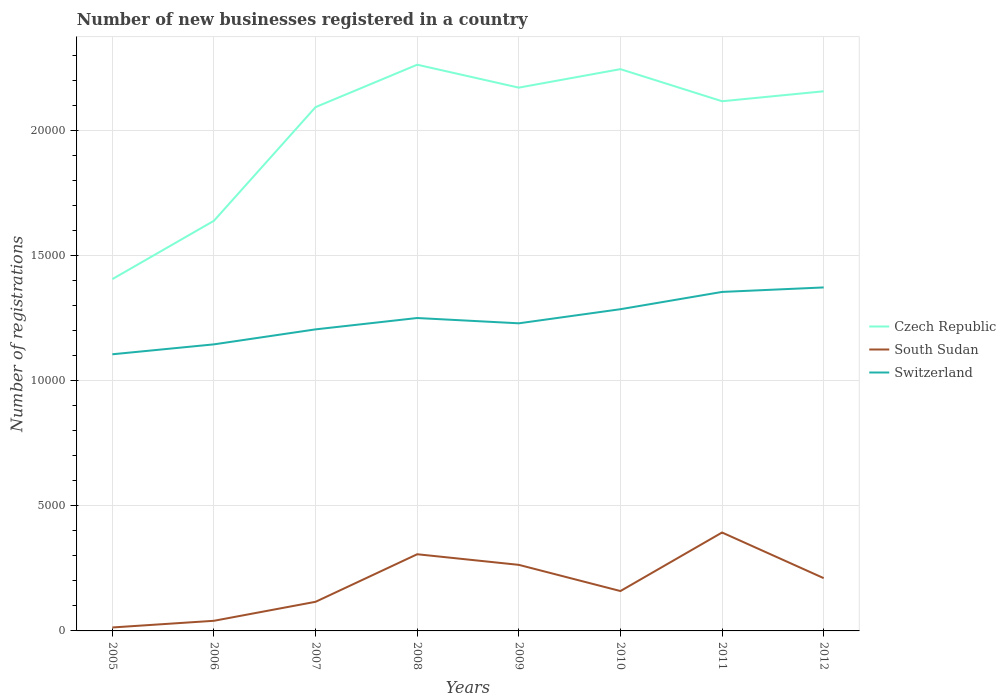Is the number of lines equal to the number of legend labels?
Keep it short and to the point. Yes. Across all years, what is the maximum number of new businesses registered in South Sudan?
Your answer should be very brief. 138. In which year was the number of new businesses registered in Czech Republic maximum?
Ensure brevity in your answer.  2005. What is the total number of new businesses registered in South Sudan in the graph?
Offer a terse response. -430. What is the difference between the highest and the second highest number of new businesses registered in Switzerland?
Make the answer very short. 2672. Is the number of new businesses registered in South Sudan strictly greater than the number of new businesses registered in Czech Republic over the years?
Your answer should be very brief. Yes. How many years are there in the graph?
Make the answer very short. 8. Does the graph contain any zero values?
Offer a terse response. No. Does the graph contain grids?
Your answer should be very brief. Yes. Where does the legend appear in the graph?
Your answer should be very brief. Center right. How many legend labels are there?
Make the answer very short. 3. What is the title of the graph?
Make the answer very short. Number of new businesses registered in a country. Does "Ecuador" appear as one of the legend labels in the graph?
Make the answer very short. No. What is the label or title of the Y-axis?
Your answer should be very brief. Number of registrations. What is the Number of registrations in Czech Republic in 2005?
Your answer should be compact. 1.41e+04. What is the Number of registrations of South Sudan in 2005?
Give a very brief answer. 138. What is the Number of registrations of Switzerland in 2005?
Keep it short and to the point. 1.11e+04. What is the Number of registrations of Czech Republic in 2006?
Ensure brevity in your answer.  1.64e+04. What is the Number of registrations of South Sudan in 2006?
Ensure brevity in your answer.  405. What is the Number of registrations in Switzerland in 2006?
Offer a very short reply. 1.15e+04. What is the Number of registrations in Czech Republic in 2007?
Your answer should be very brief. 2.09e+04. What is the Number of registrations of South Sudan in 2007?
Your answer should be compact. 1164. What is the Number of registrations of Switzerland in 2007?
Ensure brevity in your answer.  1.21e+04. What is the Number of registrations of Czech Republic in 2008?
Provide a short and direct response. 2.26e+04. What is the Number of registrations in South Sudan in 2008?
Make the answer very short. 3065. What is the Number of registrations in Switzerland in 2008?
Provide a succinct answer. 1.25e+04. What is the Number of registrations in Czech Republic in 2009?
Keep it short and to the point. 2.17e+04. What is the Number of registrations in South Sudan in 2009?
Make the answer very short. 2641. What is the Number of registrations of Switzerland in 2009?
Make the answer very short. 1.23e+04. What is the Number of registrations in Czech Republic in 2010?
Your response must be concise. 2.25e+04. What is the Number of registrations of South Sudan in 2010?
Provide a short and direct response. 1594. What is the Number of registrations of Switzerland in 2010?
Provide a succinct answer. 1.29e+04. What is the Number of registrations of Czech Republic in 2011?
Offer a terse response. 2.12e+04. What is the Number of registrations of South Sudan in 2011?
Your answer should be compact. 3934. What is the Number of registrations in Switzerland in 2011?
Keep it short and to the point. 1.36e+04. What is the Number of registrations of Czech Republic in 2012?
Ensure brevity in your answer.  2.16e+04. What is the Number of registrations in South Sudan in 2012?
Your response must be concise. 2110. What is the Number of registrations of Switzerland in 2012?
Offer a very short reply. 1.37e+04. Across all years, what is the maximum Number of registrations in Czech Republic?
Keep it short and to the point. 2.26e+04. Across all years, what is the maximum Number of registrations of South Sudan?
Provide a short and direct response. 3934. Across all years, what is the maximum Number of registrations in Switzerland?
Make the answer very short. 1.37e+04. Across all years, what is the minimum Number of registrations in Czech Republic?
Your answer should be compact. 1.41e+04. Across all years, what is the minimum Number of registrations in South Sudan?
Offer a very short reply. 138. Across all years, what is the minimum Number of registrations of Switzerland?
Your answer should be compact. 1.11e+04. What is the total Number of registrations in Czech Republic in the graph?
Provide a short and direct response. 1.61e+05. What is the total Number of registrations of South Sudan in the graph?
Provide a succinct answer. 1.51e+04. What is the total Number of registrations of Switzerland in the graph?
Your answer should be compact. 9.95e+04. What is the difference between the Number of registrations of Czech Republic in 2005 and that in 2006?
Your answer should be compact. -2333. What is the difference between the Number of registrations of South Sudan in 2005 and that in 2006?
Keep it short and to the point. -267. What is the difference between the Number of registrations of Switzerland in 2005 and that in 2006?
Provide a succinct answer. -397. What is the difference between the Number of registrations in Czech Republic in 2005 and that in 2007?
Ensure brevity in your answer.  -6876. What is the difference between the Number of registrations of South Sudan in 2005 and that in 2007?
Make the answer very short. -1026. What is the difference between the Number of registrations of Switzerland in 2005 and that in 2007?
Offer a very short reply. -996. What is the difference between the Number of registrations in Czech Republic in 2005 and that in 2008?
Provide a short and direct response. -8571. What is the difference between the Number of registrations of South Sudan in 2005 and that in 2008?
Provide a short and direct response. -2927. What is the difference between the Number of registrations of Switzerland in 2005 and that in 2008?
Keep it short and to the point. -1450. What is the difference between the Number of registrations of Czech Republic in 2005 and that in 2009?
Offer a very short reply. -7655. What is the difference between the Number of registrations in South Sudan in 2005 and that in 2009?
Keep it short and to the point. -2503. What is the difference between the Number of registrations of Switzerland in 2005 and that in 2009?
Provide a succinct answer. -1238. What is the difference between the Number of registrations of Czech Republic in 2005 and that in 2010?
Ensure brevity in your answer.  -8394. What is the difference between the Number of registrations in South Sudan in 2005 and that in 2010?
Give a very brief answer. -1456. What is the difference between the Number of registrations of Switzerland in 2005 and that in 2010?
Offer a terse response. -1802. What is the difference between the Number of registrations in Czech Republic in 2005 and that in 2011?
Provide a succinct answer. -7111. What is the difference between the Number of registrations in South Sudan in 2005 and that in 2011?
Provide a succinct answer. -3796. What is the difference between the Number of registrations of Switzerland in 2005 and that in 2011?
Make the answer very short. -2493. What is the difference between the Number of registrations in Czech Republic in 2005 and that in 2012?
Offer a terse response. -7509. What is the difference between the Number of registrations in South Sudan in 2005 and that in 2012?
Make the answer very short. -1972. What is the difference between the Number of registrations of Switzerland in 2005 and that in 2012?
Your response must be concise. -2672. What is the difference between the Number of registrations in Czech Republic in 2006 and that in 2007?
Your response must be concise. -4543. What is the difference between the Number of registrations of South Sudan in 2006 and that in 2007?
Make the answer very short. -759. What is the difference between the Number of registrations in Switzerland in 2006 and that in 2007?
Offer a very short reply. -599. What is the difference between the Number of registrations of Czech Republic in 2006 and that in 2008?
Make the answer very short. -6238. What is the difference between the Number of registrations in South Sudan in 2006 and that in 2008?
Make the answer very short. -2660. What is the difference between the Number of registrations of Switzerland in 2006 and that in 2008?
Provide a succinct answer. -1053. What is the difference between the Number of registrations of Czech Republic in 2006 and that in 2009?
Provide a succinct answer. -5322. What is the difference between the Number of registrations of South Sudan in 2006 and that in 2009?
Your response must be concise. -2236. What is the difference between the Number of registrations of Switzerland in 2006 and that in 2009?
Your answer should be compact. -841. What is the difference between the Number of registrations of Czech Republic in 2006 and that in 2010?
Ensure brevity in your answer.  -6061. What is the difference between the Number of registrations of South Sudan in 2006 and that in 2010?
Provide a succinct answer. -1189. What is the difference between the Number of registrations of Switzerland in 2006 and that in 2010?
Ensure brevity in your answer.  -1405. What is the difference between the Number of registrations in Czech Republic in 2006 and that in 2011?
Provide a succinct answer. -4778. What is the difference between the Number of registrations in South Sudan in 2006 and that in 2011?
Offer a very short reply. -3529. What is the difference between the Number of registrations of Switzerland in 2006 and that in 2011?
Keep it short and to the point. -2096. What is the difference between the Number of registrations of Czech Republic in 2006 and that in 2012?
Ensure brevity in your answer.  -5176. What is the difference between the Number of registrations of South Sudan in 2006 and that in 2012?
Your response must be concise. -1705. What is the difference between the Number of registrations of Switzerland in 2006 and that in 2012?
Provide a short and direct response. -2275. What is the difference between the Number of registrations in Czech Republic in 2007 and that in 2008?
Offer a very short reply. -1695. What is the difference between the Number of registrations of South Sudan in 2007 and that in 2008?
Your response must be concise. -1901. What is the difference between the Number of registrations of Switzerland in 2007 and that in 2008?
Offer a very short reply. -454. What is the difference between the Number of registrations of Czech Republic in 2007 and that in 2009?
Provide a short and direct response. -779. What is the difference between the Number of registrations of South Sudan in 2007 and that in 2009?
Your response must be concise. -1477. What is the difference between the Number of registrations of Switzerland in 2007 and that in 2009?
Give a very brief answer. -242. What is the difference between the Number of registrations of Czech Republic in 2007 and that in 2010?
Provide a succinct answer. -1518. What is the difference between the Number of registrations of South Sudan in 2007 and that in 2010?
Provide a short and direct response. -430. What is the difference between the Number of registrations in Switzerland in 2007 and that in 2010?
Offer a terse response. -806. What is the difference between the Number of registrations in Czech Republic in 2007 and that in 2011?
Make the answer very short. -235. What is the difference between the Number of registrations in South Sudan in 2007 and that in 2011?
Keep it short and to the point. -2770. What is the difference between the Number of registrations in Switzerland in 2007 and that in 2011?
Your response must be concise. -1497. What is the difference between the Number of registrations of Czech Republic in 2007 and that in 2012?
Offer a terse response. -633. What is the difference between the Number of registrations of South Sudan in 2007 and that in 2012?
Your answer should be very brief. -946. What is the difference between the Number of registrations in Switzerland in 2007 and that in 2012?
Ensure brevity in your answer.  -1676. What is the difference between the Number of registrations in Czech Republic in 2008 and that in 2009?
Provide a short and direct response. 916. What is the difference between the Number of registrations in South Sudan in 2008 and that in 2009?
Keep it short and to the point. 424. What is the difference between the Number of registrations in Switzerland in 2008 and that in 2009?
Offer a very short reply. 212. What is the difference between the Number of registrations in Czech Republic in 2008 and that in 2010?
Give a very brief answer. 177. What is the difference between the Number of registrations in South Sudan in 2008 and that in 2010?
Make the answer very short. 1471. What is the difference between the Number of registrations of Switzerland in 2008 and that in 2010?
Your answer should be very brief. -352. What is the difference between the Number of registrations of Czech Republic in 2008 and that in 2011?
Ensure brevity in your answer.  1460. What is the difference between the Number of registrations of South Sudan in 2008 and that in 2011?
Your answer should be compact. -869. What is the difference between the Number of registrations in Switzerland in 2008 and that in 2011?
Provide a short and direct response. -1043. What is the difference between the Number of registrations in Czech Republic in 2008 and that in 2012?
Provide a succinct answer. 1062. What is the difference between the Number of registrations in South Sudan in 2008 and that in 2012?
Offer a very short reply. 955. What is the difference between the Number of registrations in Switzerland in 2008 and that in 2012?
Offer a terse response. -1222. What is the difference between the Number of registrations in Czech Republic in 2009 and that in 2010?
Provide a succinct answer. -739. What is the difference between the Number of registrations in South Sudan in 2009 and that in 2010?
Your answer should be compact. 1047. What is the difference between the Number of registrations in Switzerland in 2009 and that in 2010?
Offer a terse response. -564. What is the difference between the Number of registrations in Czech Republic in 2009 and that in 2011?
Ensure brevity in your answer.  544. What is the difference between the Number of registrations in South Sudan in 2009 and that in 2011?
Keep it short and to the point. -1293. What is the difference between the Number of registrations in Switzerland in 2009 and that in 2011?
Make the answer very short. -1255. What is the difference between the Number of registrations of Czech Republic in 2009 and that in 2012?
Keep it short and to the point. 146. What is the difference between the Number of registrations in South Sudan in 2009 and that in 2012?
Ensure brevity in your answer.  531. What is the difference between the Number of registrations in Switzerland in 2009 and that in 2012?
Provide a short and direct response. -1434. What is the difference between the Number of registrations in Czech Republic in 2010 and that in 2011?
Your response must be concise. 1283. What is the difference between the Number of registrations in South Sudan in 2010 and that in 2011?
Ensure brevity in your answer.  -2340. What is the difference between the Number of registrations of Switzerland in 2010 and that in 2011?
Keep it short and to the point. -691. What is the difference between the Number of registrations in Czech Republic in 2010 and that in 2012?
Your answer should be very brief. 885. What is the difference between the Number of registrations of South Sudan in 2010 and that in 2012?
Give a very brief answer. -516. What is the difference between the Number of registrations in Switzerland in 2010 and that in 2012?
Your response must be concise. -870. What is the difference between the Number of registrations of Czech Republic in 2011 and that in 2012?
Your response must be concise. -398. What is the difference between the Number of registrations of South Sudan in 2011 and that in 2012?
Ensure brevity in your answer.  1824. What is the difference between the Number of registrations of Switzerland in 2011 and that in 2012?
Your answer should be compact. -179. What is the difference between the Number of registrations in Czech Republic in 2005 and the Number of registrations in South Sudan in 2006?
Provide a succinct answer. 1.37e+04. What is the difference between the Number of registrations of Czech Republic in 2005 and the Number of registrations of Switzerland in 2006?
Ensure brevity in your answer.  2607. What is the difference between the Number of registrations of South Sudan in 2005 and the Number of registrations of Switzerland in 2006?
Offer a terse response. -1.13e+04. What is the difference between the Number of registrations of Czech Republic in 2005 and the Number of registrations of South Sudan in 2007?
Your answer should be very brief. 1.29e+04. What is the difference between the Number of registrations in Czech Republic in 2005 and the Number of registrations in Switzerland in 2007?
Your answer should be very brief. 2008. What is the difference between the Number of registrations of South Sudan in 2005 and the Number of registrations of Switzerland in 2007?
Your response must be concise. -1.19e+04. What is the difference between the Number of registrations in Czech Republic in 2005 and the Number of registrations in South Sudan in 2008?
Keep it short and to the point. 1.10e+04. What is the difference between the Number of registrations in Czech Republic in 2005 and the Number of registrations in Switzerland in 2008?
Your answer should be very brief. 1554. What is the difference between the Number of registrations in South Sudan in 2005 and the Number of registrations in Switzerland in 2008?
Provide a short and direct response. -1.24e+04. What is the difference between the Number of registrations in Czech Republic in 2005 and the Number of registrations in South Sudan in 2009?
Make the answer very short. 1.14e+04. What is the difference between the Number of registrations of Czech Republic in 2005 and the Number of registrations of Switzerland in 2009?
Provide a succinct answer. 1766. What is the difference between the Number of registrations in South Sudan in 2005 and the Number of registrations in Switzerland in 2009?
Your response must be concise. -1.22e+04. What is the difference between the Number of registrations of Czech Republic in 2005 and the Number of registrations of South Sudan in 2010?
Make the answer very short. 1.25e+04. What is the difference between the Number of registrations in Czech Republic in 2005 and the Number of registrations in Switzerland in 2010?
Keep it short and to the point. 1202. What is the difference between the Number of registrations in South Sudan in 2005 and the Number of registrations in Switzerland in 2010?
Your response must be concise. -1.27e+04. What is the difference between the Number of registrations of Czech Republic in 2005 and the Number of registrations of South Sudan in 2011?
Your response must be concise. 1.01e+04. What is the difference between the Number of registrations of Czech Republic in 2005 and the Number of registrations of Switzerland in 2011?
Keep it short and to the point. 511. What is the difference between the Number of registrations in South Sudan in 2005 and the Number of registrations in Switzerland in 2011?
Your response must be concise. -1.34e+04. What is the difference between the Number of registrations of Czech Republic in 2005 and the Number of registrations of South Sudan in 2012?
Give a very brief answer. 1.20e+04. What is the difference between the Number of registrations of Czech Republic in 2005 and the Number of registrations of Switzerland in 2012?
Offer a very short reply. 332. What is the difference between the Number of registrations in South Sudan in 2005 and the Number of registrations in Switzerland in 2012?
Make the answer very short. -1.36e+04. What is the difference between the Number of registrations of Czech Republic in 2006 and the Number of registrations of South Sudan in 2007?
Keep it short and to the point. 1.52e+04. What is the difference between the Number of registrations of Czech Republic in 2006 and the Number of registrations of Switzerland in 2007?
Your answer should be compact. 4341. What is the difference between the Number of registrations in South Sudan in 2006 and the Number of registrations in Switzerland in 2007?
Provide a succinct answer. -1.16e+04. What is the difference between the Number of registrations of Czech Republic in 2006 and the Number of registrations of South Sudan in 2008?
Give a very brief answer. 1.33e+04. What is the difference between the Number of registrations of Czech Republic in 2006 and the Number of registrations of Switzerland in 2008?
Offer a terse response. 3887. What is the difference between the Number of registrations of South Sudan in 2006 and the Number of registrations of Switzerland in 2008?
Your response must be concise. -1.21e+04. What is the difference between the Number of registrations of Czech Republic in 2006 and the Number of registrations of South Sudan in 2009?
Make the answer very short. 1.38e+04. What is the difference between the Number of registrations in Czech Republic in 2006 and the Number of registrations in Switzerland in 2009?
Make the answer very short. 4099. What is the difference between the Number of registrations of South Sudan in 2006 and the Number of registrations of Switzerland in 2009?
Ensure brevity in your answer.  -1.19e+04. What is the difference between the Number of registrations of Czech Republic in 2006 and the Number of registrations of South Sudan in 2010?
Ensure brevity in your answer.  1.48e+04. What is the difference between the Number of registrations in Czech Republic in 2006 and the Number of registrations in Switzerland in 2010?
Provide a short and direct response. 3535. What is the difference between the Number of registrations in South Sudan in 2006 and the Number of registrations in Switzerland in 2010?
Give a very brief answer. -1.25e+04. What is the difference between the Number of registrations in Czech Republic in 2006 and the Number of registrations in South Sudan in 2011?
Make the answer very short. 1.25e+04. What is the difference between the Number of registrations in Czech Republic in 2006 and the Number of registrations in Switzerland in 2011?
Ensure brevity in your answer.  2844. What is the difference between the Number of registrations of South Sudan in 2006 and the Number of registrations of Switzerland in 2011?
Offer a terse response. -1.31e+04. What is the difference between the Number of registrations of Czech Republic in 2006 and the Number of registrations of South Sudan in 2012?
Make the answer very short. 1.43e+04. What is the difference between the Number of registrations of Czech Republic in 2006 and the Number of registrations of Switzerland in 2012?
Your answer should be compact. 2665. What is the difference between the Number of registrations of South Sudan in 2006 and the Number of registrations of Switzerland in 2012?
Make the answer very short. -1.33e+04. What is the difference between the Number of registrations of Czech Republic in 2007 and the Number of registrations of South Sudan in 2008?
Your answer should be very brief. 1.79e+04. What is the difference between the Number of registrations in Czech Republic in 2007 and the Number of registrations in Switzerland in 2008?
Your answer should be compact. 8430. What is the difference between the Number of registrations in South Sudan in 2007 and the Number of registrations in Switzerland in 2008?
Give a very brief answer. -1.13e+04. What is the difference between the Number of registrations of Czech Republic in 2007 and the Number of registrations of South Sudan in 2009?
Ensure brevity in your answer.  1.83e+04. What is the difference between the Number of registrations in Czech Republic in 2007 and the Number of registrations in Switzerland in 2009?
Your answer should be compact. 8642. What is the difference between the Number of registrations of South Sudan in 2007 and the Number of registrations of Switzerland in 2009?
Ensure brevity in your answer.  -1.11e+04. What is the difference between the Number of registrations in Czech Republic in 2007 and the Number of registrations in South Sudan in 2010?
Ensure brevity in your answer.  1.93e+04. What is the difference between the Number of registrations of Czech Republic in 2007 and the Number of registrations of Switzerland in 2010?
Keep it short and to the point. 8078. What is the difference between the Number of registrations in South Sudan in 2007 and the Number of registrations in Switzerland in 2010?
Provide a short and direct response. -1.17e+04. What is the difference between the Number of registrations in Czech Republic in 2007 and the Number of registrations in South Sudan in 2011?
Your response must be concise. 1.70e+04. What is the difference between the Number of registrations in Czech Republic in 2007 and the Number of registrations in Switzerland in 2011?
Give a very brief answer. 7387. What is the difference between the Number of registrations of South Sudan in 2007 and the Number of registrations of Switzerland in 2011?
Give a very brief answer. -1.24e+04. What is the difference between the Number of registrations of Czech Republic in 2007 and the Number of registrations of South Sudan in 2012?
Keep it short and to the point. 1.88e+04. What is the difference between the Number of registrations of Czech Republic in 2007 and the Number of registrations of Switzerland in 2012?
Offer a very short reply. 7208. What is the difference between the Number of registrations in South Sudan in 2007 and the Number of registrations in Switzerland in 2012?
Your response must be concise. -1.26e+04. What is the difference between the Number of registrations in Czech Republic in 2008 and the Number of registrations in South Sudan in 2009?
Offer a terse response. 2.00e+04. What is the difference between the Number of registrations of Czech Republic in 2008 and the Number of registrations of Switzerland in 2009?
Provide a succinct answer. 1.03e+04. What is the difference between the Number of registrations in South Sudan in 2008 and the Number of registrations in Switzerland in 2009?
Provide a short and direct response. -9231. What is the difference between the Number of registrations in Czech Republic in 2008 and the Number of registrations in South Sudan in 2010?
Make the answer very short. 2.10e+04. What is the difference between the Number of registrations in Czech Republic in 2008 and the Number of registrations in Switzerland in 2010?
Make the answer very short. 9773. What is the difference between the Number of registrations in South Sudan in 2008 and the Number of registrations in Switzerland in 2010?
Your response must be concise. -9795. What is the difference between the Number of registrations in Czech Republic in 2008 and the Number of registrations in South Sudan in 2011?
Offer a terse response. 1.87e+04. What is the difference between the Number of registrations of Czech Republic in 2008 and the Number of registrations of Switzerland in 2011?
Your answer should be compact. 9082. What is the difference between the Number of registrations of South Sudan in 2008 and the Number of registrations of Switzerland in 2011?
Provide a short and direct response. -1.05e+04. What is the difference between the Number of registrations of Czech Republic in 2008 and the Number of registrations of South Sudan in 2012?
Make the answer very short. 2.05e+04. What is the difference between the Number of registrations of Czech Republic in 2008 and the Number of registrations of Switzerland in 2012?
Make the answer very short. 8903. What is the difference between the Number of registrations in South Sudan in 2008 and the Number of registrations in Switzerland in 2012?
Offer a terse response. -1.07e+04. What is the difference between the Number of registrations of Czech Republic in 2009 and the Number of registrations of South Sudan in 2010?
Provide a short and direct response. 2.01e+04. What is the difference between the Number of registrations in Czech Republic in 2009 and the Number of registrations in Switzerland in 2010?
Your response must be concise. 8857. What is the difference between the Number of registrations of South Sudan in 2009 and the Number of registrations of Switzerland in 2010?
Your answer should be compact. -1.02e+04. What is the difference between the Number of registrations in Czech Republic in 2009 and the Number of registrations in South Sudan in 2011?
Provide a succinct answer. 1.78e+04. What is the difference between the Number of registrations of Czech Republic in 2009 and the Number of registrations of Switzerland in 2011?
Ensure brevity in your answer.  8166. What is the difference between the Number of registrations in South Sudan in 2009 and the Number of registrations in Switzerland in 2011?
Your response must be concise. -1.09e+04. What is the difference between the Number of registrations of Czech Republic in 2009 and the Number of registrations of South Sudan in 2012?
Your answer should be compact. 1.96e+04. What is the difference between the Number of registrations in Czech Republic in 2009 and the Number of registrations in Switzerland in 2012?
Offer a very short reply. 7987. What is the difference between the Number of registrations in South Sudan in 2009 and the Number of registrations in Switzerland in 2012?
Provide a succinct answer. -1.11e+04. What is the difference between the Number of registrations of Czech Republic in 2010 and the Number of registrations of South Sudan in 2011?
Give a very brief answer. 1.85e+04. What is the difference between the Number of registrations in Czech Republic in 2010 and the Number of registrations in Switzerland in 2011?
Make the answer very short. 8905. What is the difference between the Number of registrations of South Sudan in 2010 and the Number of registrations of Switzerland in 2011?
Your answer should be compact. -1.20e+04. What is the difference between the Number of registrations in Czech Republic in 2010 and the Number of registrations in South Sudan in 2012?
Provide a short and direct response. 2.03e+04. What is the difference between the Number of registrations in Czech Republic in 2010 and the Number of registrations in Switzerland in 2012?
Ensure brevity in your answer.  8726. What is the difference between the Number of registrations of South Sudan in 2010 and the Number of registrations of Switzerland in 2012?
Ensure brevity in your answer.  -1.21e+04. What is the difference between the Number of registrations of Czech Republic in 2011 and the Number of registrations of South Sudan in 2012?
Keep it short and to the point. 1.91e+04. What is the difference between the Number of registrations of Czech Republic in 2011 and the Number of registrations of Switzerland in 2012?
Ensure brevity in your answer.  7443. What is the difference between the Number of registrations in South Sudan in 2011 and the Number of registrations in Switzerland in 2012?
Make the answer very short. -9796. What is the average Number of registrations of Czech Republic per year?
Provide a succinct answer. 2.01e+04. What is the average Number of registrations of South Sudan per year?
Your answer should be compact. 1881.38. What is the average Number of registrations in Switzerland per year?
Your response must be concise. 1.24e+04. In the year 2005, what is the difference between the Number of registrations of Czech Republic and Number of registrations of South Sudan?
Provide a succinct answer. 1.39e+04. In the year 2005, what is the difference between the Number of registrations of Czech Republic and Number of registrations of Switzerland?
Make the answer very short. 3004. In the year 2005, what is the difference between the Number of registrations in South Sudan and Number of registrations in Switzerland?
Make the answer very short. -1.09e+04. In the year 2006, what is the difference between the Number of registrations of Czech Republic and Number of registrations of South Sudan?
Your response must be concise. 1.60e+04. In the year 2006, what is the difference between the Number of registrations in Czech Republic and Number of registrations in Switzerland?
Your response must be concise. 4940. In the year 2006, what is the difference between the Number of registrations in South Sudan and Number of registrations in Switzerland?
Give a very brief answer. -1.10e+04. In the year 2007, what is the difference between the Number of registrations in Czech Republic and Number of registrations in South Sudan?
Your response must be concise. 1.98e+04. In the year 2007, what is the difference between the Number of registrations of Czech Republic and Number of registrations of Switzerland?
Provide a succinct answer. 8884. In the year 2007, what is the difference between the Number of registrations in South Sudan and Number of registrations in Switzerland?
Provide a short and direct response. -1.09e+04. In the year 2008, what is the difference between the Number of registrations of Czech Republic and Number of registrations of South Sudan?
Ensure brevity in your answer.  1.96e+04. In the year 2008, what is the difference between the Number of registrations in Czech Republic and Number of registrations in Switzerland?
Give a very brief answer. 1.01e+04. In the year 2008, what is the difference between the Number of registrations of South Sudan and Number of registrations of Switzerland?
Make the answer very short. -9443. In the year 2009, what is the difference between the Number of registrations in Czech Republic and Number of registrations in South Sudan?
Make the answer very short. 1.91e+04. In the year 2009, what is the difference between the Number of registrations of Czech Republic and Number of registrations of Switzerland?
Your answer should be very brief. 9421. In the year 2009, what is the difference between the Number of registrations of South Sudan and Number of registrations of Switzerland?
Offer a very short reply. -9655. In the year 2010, what is the difference between the Number of registrations of Czech Republic and Number of registrations of South Sudan?
Offer a terse response. 2.09e+04. In the year 2010, what is the difference between the Number of registrations in Czech Republic and Number of registrations in Switzerland?
Your answer should be compact. 9596. In the year 2010, what is the difference between the Number of registrations in South Sudan and Number of registrations in Switzerland?
Offer a terse response. -1.13e+04. In the year 2011, what is the difference between the Number of registrations in Czech Republic and Number of registrations in South Sudan?
Keep it short and to the point. 1.72e+04. In the year 2011, what is the difference between the Number of registrations of Czech Republic and Number of registrations of Switzerland?
Offer a very short reply. 7622. In the year 2011, what is the difference between the Number of registrations of South Sudan and Number of registrations of Switzerland?
Your answer should be compact. -9617. In the year 2012, what is the difference between the Number of registrations in Czech Republic and Number of registrations in South Sudan?
Give a very brief answer. 1.95e+04. In the year 2012, what is the difference between the Number of registrations in Czech Republic and Number of registrations in Switzerland?
Your answer should be very brief. 7841. In the year 2012, what is the difference between the Number of registrations of South Sudan and Number of registrations of Switzerland?
Make the answer very short. -1.16e+04. What is the ratio of the Number of registrations of Czech Republic in 2005 to that in 2006?
Give a very brief answer. 0.86. What is the ratio of the Number of registrations in South Sudan in 2005 to that in 2006?
Your answer should be compact. 0.34. What is the ratio of the Number of registrations in Switzerland in 2005 to that in 2006?
Ensure brevity in your answer.  0.97. What is the ratio of the Number of registrations in Czech Republic in 2005 to that in 2007?
Provide a succinct answer. 0.67. What is the ratio of the Number of registrations in South Sudan in 2005 to that in 2007?
Ensure brevity in your answer.  0.12. What is the ratio of the Number of registrations in Switzerland in 2005 to that in 2007?
Ensure brevity in your answer.  0.92. What is the ratio of the Number of registrations of Czech Republic in 2005 to that in 2008?
Your answer should be very brief. 0.62. What is the ratio of the Number of registrations of South Sudan in 2005 to that in 2008?
Provide a succinct answer. 0.04. What is the ratio of the Number of registrations of Switzerland in 2005 to that in 2008?
Your response must be concise. 0.88. What is the ratio of the Number of registrations in Czech Republic in 2005 to that in 2009?
Offer a terse response. 0.65. What is the ratio of the Number of registrations in South Sudan in 2005 to that in 2009?
Your answer should be compact. 0.05. What is the ratio of the Number of registrations in Switzerland in 2005 to that in 2009?
Your response must be concise. 0.9. What is the ratio of the Number of registrations of Czech Republic in 2005 to that in 2010?
Make the answer very short. 0.63. What is the ratio of the Number of registrations in South Sudan in 2005 to that in 2010?
Provide a short and direct response. 0.09. What is the ratio of the Number of registrations of Switzerland in 2005 to that in 2010?
Offer a very short reply. 0.86. What is the ratio of the Number of registrations in Czech Republic in 2005 to that in 2011?
Provide a short and direct response. 0.66. What is the ratio of the Number of registrations of South Sudan in 2005 to that in 2011?
Make the answer very short. 0.04. What is the ratio of the Number of registrations of Switzerland in 2005 to that in 2011?
Offer a terse response. 0.82. What is the ratio of the Number of registrations of Czech Republic in 2005 to that in 2012?
Ensure brevity in your answer.  0.65. What is the ratio of the Number of registrations of South Sudan in 2005 to that in 2012?
Your answer should be compact. 0.07. What is the ratio of the Number of registrations of Switzerland in 2005 to that in 2012?
Offer a terse response. 0.81. What is the ratio of the Number of registrations in Czech Republic in 2006 to that in 2007?
Provide a succinct answer. 0.78. What is the ratio of the Number of registrations in South Sudan in 2006 to that in 2007?
Offer a terse response. 0.35. What is the ratio of the Number of registrations in Switzerland in 2006 to that in 2007?
Offer a very short reply. 0.95. What is the ratio of the Number of registrations of Czech Republic in 2006 to that in 2008?
Offer a terse response. 0.72. What is the ratio of the Number of registrations of South Sudan in 2006 to that in 2008?
Make the answer very short. 0.13. What is the ratio of the Number of registrations of Switzerland in 2006 to that in 2008?
Offer a terse response. 0.92. What is the ratio of the Number of registrations of Czech Republic in 2006 to that in 2009?
Your response must be concise. 0.75. What is the ratio of the Number of registrations of South Sudan in 2006 to that in 2009?
Your response must be concise. 0.15. What is the ratio of the Number of registrations of Switzerland in 2006 to that in 2009?
Your response must be concise. 0.93. What is the ratio of the Number of registrations in Czech Republic in 2006 to that in 2010?
Offer a terse response. 0.73. What is the ratio of the Number of registrations of South Sudan in 2006 to that in 2010?
Ensure brevity in your answer.  0.25. What is the ratio of the Number of registrations in Switzerland in 2006 to that in 2010?
Ensure brevity in your answer.  0.89. What is the ratio of the Number of registrations in Czech Republic in 2006 to that in 2011?
Ensure brevity in your answer.  0.77. What is the ratio of the Number of registrations of South Sudan in 2006 to that in 2011?
Ensure brevity in your answer.  0.1. What is the ratio of the Number of registrations in Switzerland in 2006 to that in 2011?
Make the answer very short. 0.85. What is the ratio of the Number of registrations in Czech Republic in 2006 to that in 2012?
Offer a terse response. 0.76. What is the ratio of the Number of registrations of South Sudan in 2006 to that in 2012?
Make the answer very short. 0.19. What is the ratio of the Number of registrations in Switzerland in 2006 to that in 2012?
Keep it short and to the point. 0.83. What is the ratio of the Number of registrations in Czech Republic in 2007 to that in 2008?
Offer a very short reply. 0.93. What is the ratio of the Number of registrations of South Sudan in 2007 to that in 2008?
Your answer should be very brief. 0.38. What is the ratio of the Number of registrations of Switzerland in 2007 to that in 2008?
Your answer should be compact. 0.96. What is the ratio of the Number of registrations of Czech Republic in 2007 to that in 2009?
Offer a terse response. 0.96. What is the ratio of the Number of registrations of South Sudan in 2007 to that in 2009?
Give a very brief answer. 0.44. What is the ratio of the Number of registrations in Switzerland in 2007 to that in 2009?
Your response must be concise. 0.98. What is the ratio of the Number of registrations in Czech Republic in 2007 to that in 2010?
Your answer should be very brief. 0.93. What is the ratio of the Number of registrations in South Sudan in 2007 to that in 2010?
Your response must be concise. 0.73. What is the ratio of the Number of registrations of Switzerland in 2007 to that in 2010?
Give a very brief answer. 0.94. What is the ratio of the Number of registrations of Czech Republic in 2007 to that in 2011?
Make the answer very short. 0.99. What is the ratio of the Number of registrations of South Sudan in 2007 to that in 2011?
Keep it short and to the point. 0.3. What is the ratio of the Number of registrations in Switzerland in 2007 to that in 2011?
Give a very brief answer. 0.89. What is the ratio of the Number of registrations of Czech Republic in 2007 to that in 2012?
Keep it short and to the point. 0.97. What is the ratio of the Number of registrations in South Sudan in 2007 to that in 2012?
Make the answer very short. 0.55. What is the ratio of the Number of registrations in Switzerland in 2007 to that in 2012?
Keep it short and to the point. 0.88. What is the ratio of the Number of registrations in Czech Republic in 2008 to that in 2009?
Provide a succinct answer. 1.04. What is the ratio of the Number of registrations of South Sudan in 2008 to that in 2009?
Your response must be concise. 1.16. What is the ratio of the Number of registrations in Switzerland in 2008 to that in 2009?
Your answer should be very brief. 1.02. What is the ratio of the Number of registrations in Czech Republic in 2008 to that in 2010?
Offer a terse response. 1.01. What is the ratio of the Number of registrations in South Sudan in 2008 to that in 2010?
Keep it short and to the point. 1.92. What is the ratio of the Number of registrations of Switzerland in 2008 to that in 2010?
Give a very brief answer. 0.97. What is the ratio of the Number of registrations in Czech Republic in 2008 to that in 2011?
Ensure brevity in your answer.  1.07. What is the ratio of the Number of registrations in South Sudan in 2008 to that in 2011?
Your answer should be very brief. 0.78. What is the ratio of the Number of registrations in Switzerland in 2008 to that in 2011?
Keep it short and to the point. 0.92. What is the ratio of the Number of registrations of Czech Republic in 2008 to that in 2012?
Offer a very short reply. 1.05. What is the ratio of the Number of registrations of South Sudan in 2008 to that in 2012?
Offer a very short reply. 1.45. What is the ratio of the Number of registrations in Switzerland in 2008 to that in 2012?
Give a very brief answer. 0.91. What is the ratio of the Number of registrations of Czech Republic in 2009 to that in 2010?
Provide a short and direct response. 0.97. What is the ratio of the Number of registrations in South Sudan in 2009 to that in 2010?
Provide a succinct answer. 1.66. What is the ratio of the Number of registrations of Switzerland in 2009 to that in 2010?
Ensure brevity in your answer.  0.96. What is the ratio of the Number of registrations in Czech Republic in 2009 to that in 2011?
Your response must be concise. 1.03. What is the ratio of the Number of registrations of South Sudan in 2009 to that in 2011?
Give a very brief answer. 0.67. What is the ratio of the Number of registrations in Switzerland in 2009 to that in 2011?
Keep it short and to the point. 0.91. What is the ratio of the Number of registrations in Czech Republic in 2009 to that in 2012?
Make the answer very short. 1.01. What is the ratio of the Number of registrations in South Sudan in 2009 to that in 2012?
Make the answer very short. 1.25. What is the ratio of the Number of registrations in Switzerland in 2009 to that in 2012?
Your answer should be very brief. 0.9. What is the ratio of the Number of registrations of Czech Republic in 2010 to that in 2011?
Keep it short and to the point. 1.06. What is the ratio of the Number of registrations in South Sudan in 2010 to that in 2011?
Ensure brevity in your answer.  0.41. What is the ratio of the Number of registrations of Switzerland in 2010 to that in 2011?
Keep it short and to the point. 0.95. What is the ratio of the Number of registrations in Czech Republic in 2010 to that in 2012?
Your response must be concise. 1.04. What is the ratio of the Number of registrations of South Sudan in 2010 to that in 2012?
Offer a terse response. 0.76. What is the ratio of the Number of registrations in Switzerland in 2010 to that in 2012?
Your answer should be compact. 0.94. What is the ratio of the Number of registrations of Czech Republic in 2011 to that in 2012?
Ensure brevity in your answer.  0.98. What is the ratio of the Number of registrations in South Sudan in 2011 to that in 2012?
Give a very brief answer. 1.86. What is the difference between the highest and the second highest Number of registrations in Czech Republic?
Give a very brief answer. 177. What is the difference between the highest and the second highest Number of registrations in South Sudan?
Your answer should be very brief. 869. What is the difference between the highest and the second highest Number of registrations in Switzerland?
Your answer should be very brief. 179. What is the difference between the highest and the lowest Number of registrations of Czech Republic?
Your answer should be very brief. 8571. What is the difference between the highest and the lowest Number of registrations of South Sudan?
Offer a very short reply. 3796. What is the difference between the highest and the lowest Number of registrations of Switzerland?
Keep it short and to the point. 2672. 